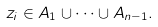Convert formula to latex. <formula><loc_0><loc_0><loc_500><loc_500>z _ { i } \in A _ { 1 } \cup \cdots \cup A _ { n - 1 } .</formula> 